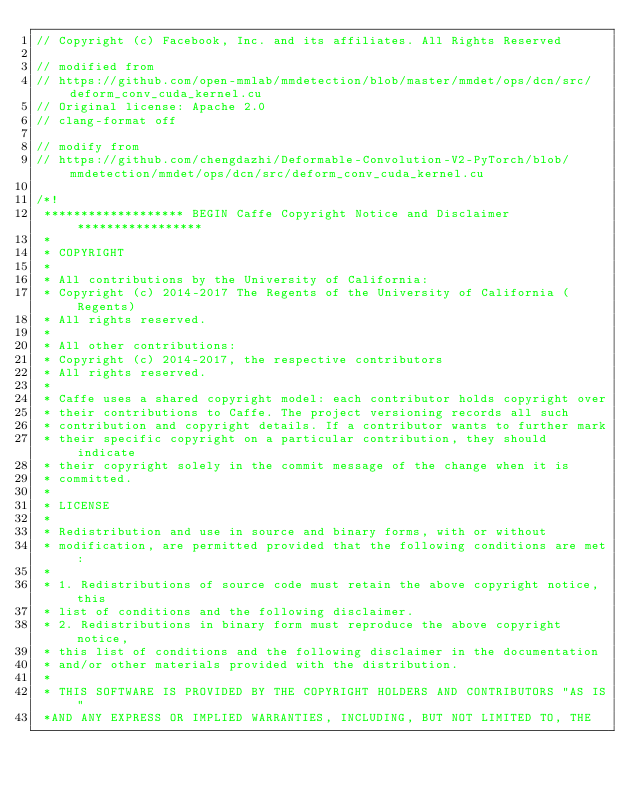Convert code to text. <code><loc_0><loc_0><loc_500><loc_500><_Cuda_>// Copyright (c) Facebook, Inc. and its affiliates. All Rights Reserved

// modified from
// https://github.com/open-mmlab/mmdetection/blob/master/mmdet/ops/dcn/src/deform_conv_cuda_kernel.cu
// Original license: Apache 2.0
// clang-format off

// modify from
// https://github.com/chengdazhi/Deformable-Convolution-V2-PyTorch/blob/mmdetection/mmdet/ops/dcn/src/deform_conv_cuda_kernel.cu

/*!
 ******************* BEGIN Caffe Copyright Notice and Disclaimer *****************
 *
 * COPYRIGHT
 *
 * All contributions by the University of California:
 * Copyright (c) 2014-2017 The Regents of the University of California (Regents)
 * All rights reserved.
 *
 * All other contributions:
 * Copyright (c) 2014-2017, the respective contributors
 * All rights reserved.
 *
 * Caffe uses a shared copyright model: each contributor holds copyright over
 * their contributions to Caffe. The project versioning records all such
 * contribution and copyright details. If a contributor wants to further mark
 * their specific copyright on a particular contribution, they should indicate
 * their copyright solely in the commit message of the change when it is
 * committed.
 *
 * LICENSE
 *
 * Redistribution and use in source and binary forms, with or without
 * modification, are permitted provided that the following conditions are met:
 *
 * 1. Redistributions of source code must retain the above copyright notice, this
 * list of conditions and the following disclaimer.
 * 2. Redistributions in binary form must reproduce the above copyright notice,
 * this list of conditions and the following disclaimer in the documentation
 * and/or other materials provided with the distribution.
 *
 * THIS SOFTWARE IS PROVIDED BY THE COPYRIGHT HOLDERS AND CONTRIBUTORS "AS IS"
 *AND ANY EXPRESS OR IMPLIED WARRANTIES, INCLUDING, BUT NOT LIMITED TO, THE</code> 